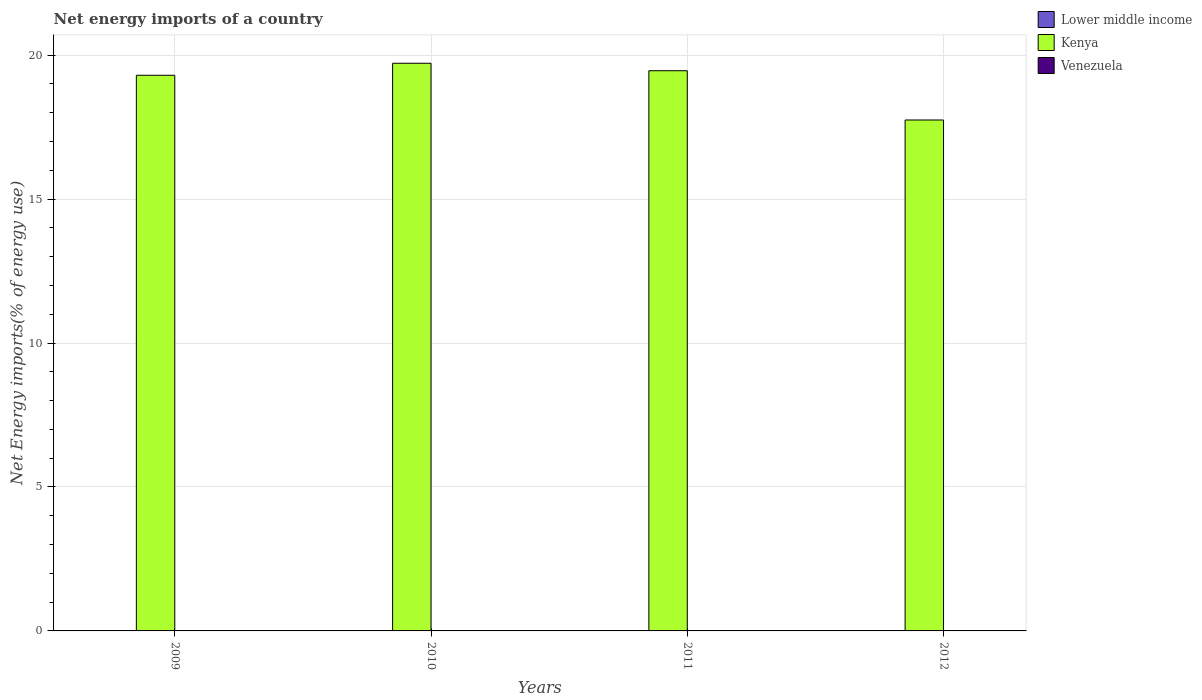How many different coloured bars are there?
Make the answer very short. 1. Are the number of bars on each tick of the X-axis equal?
Provide a short and direct response. Yes. How many bars are there on the 4th tick from the right?
Keep it short and to the point. 1. What is the label of the 3rd group of bars from the left?
Your answer should be very brief. 2011. In how many cases, is the number of bars for a given year not equal to the number of legend labels?
Keep it short and to the point. 4. What is the net energy imports in Kenya in 2010?
Your response must be concise. 19.72. Across all years, what is the maximum net energy imports in Kenya?
Make the answer very short. 19.72. What is the total net energy imports in Kenya in the graph?
Your answer should be very brief. 76.22. What is the difference between the net energy imports in Kenya in 2010 and that in 2011?
Offer a terse response. 0.26. What is the difference between the net energy imports in Kenya in 2011 and the net energy imports in Lower middle income in 2012?
Make the answer very short. 19.46. What is the average net energy imports in Venezuela per year?
Make the answer very short. 0. What is the ratio of the net energy imports in Kenya in 2011 to that in 2012?
Give a very brief answer. 1.1. What is the difference between the highest and the second highest net energy imports in Kenya?
Your answer should be compact. 0.26. What is the difference between the highest and the lowest net energy imports in Kenya?
Make the answer very short. 1.97. Is the sum of the net energy imports in Kenya in 2009 and 2011 greater than the maximum net energy imports in Venezuela across all years?
Offer a very short reply. Yes. How many bars are there?
Your response must be concise. 4. Are all the bars in the graph horizontal?
Give a very brief answer. No. What is the difference between two consecutive major ticks on the Y-axis?
Your answer should be compact. 5. Are the values on the major ticks of Y-axis written in scientific E-notation?
Your response must be concise. No. Does the graph contain any zero values?
Offer a very short reply. Yes. Does the graph contain grids?
Your answer should be very brief. Yes. How many legend labels are there?
Provide a short and direct response. 3. What is the title of the graph?
Provide a short and direct response. Net energy imports of a country. Does "Ghana" appear as one of the legend labels in the graph?
Your response must be concise. No. What is the label or title of the X-axis?
Make the answer very short. Years. What is the label or title of the Y-axis?
Provide a short and direct response. Net Energy imports(% of energy use). What is the Net Energy imports(% of energy use) of Kenya in 2009?
Keep it short and to the point. 19.3. What is the Net Energy imports(% of energy use) of Kenya in 2010?
Provide a short and direct response. 19.72. What is the Net Energy imports(% of energy use) in Venezuela in 2010?
Provide a succinct answer. 0. What is the Net Energy imports(% of energy use) in Kenya in 2011?
Your answer should be compact. 19.46. What is the Net Energy imports(% of energy use) in Kenya in 2012?
Ensure brevity in your answer.  17.75. Across all years, what is the maximum Net Energy imports(% of energy use) in Kenya?
Give a very brief answer. 19.72. Across all years, what is the minimum Net Energy imports(% of energy use) of Kenya?
Your answer should be compact. 17.75. What is the total Net Energy imports(% of energy use) of Lower middle income in the graph?
Offer a terse response. 0. What is the total Net Energy imports(% of energy use) in Kenya in the graph?
Make the answer very short. 76.22. What is the difference between the Net Energy imports(% of energy use) in Kenya in 2009 and that in 2010?
Provide a succinct answer. -0.42. What is the difference between the Net Energy imports(% of energy use) of Kenya in 2009 and that in 2011?
Ensure brevity in your answer.  -0.16. What is the difference between the Net Energy imports(% of energy use) of Kenya in 2009 and that in 2012?
Your answer should be compact. 1.55. What is the difference between the Net Energy imports(% of energy use) in Kenya in 2010 and that in 2011?
Keep it short and to the point. 0.26. What is the difference between the Net Energy imports(% of energy use) of Kenya in 2010 and that in 2012?
Give a very brief answer. 1.97. What is the difference between the Net Energy imports(% of energy use) of Kenya in 2011 and that in 2012?
Offer a very short reply. 1.71. What is the average Net Energy imports(% of energy use) of Lower middle income per year?
Your answer should be very brief. 0. What is the average Net Energy imports(% of energy use) in Kenya per year?
Keep it short and to the point. 19.05. What is the ratio of the Net Energy imports(% of energy use) in Kenya in 2009 to that in 2010?
Make the answer very short. 0.98. What is the ratio of the Net Energy imports(% of energy use) in Kenya in 2009 to that in 2011?
Your answer should be very brief. 0.99. What is the ratio of the Net Energy imports(% of energy use) of Kenya in 2009 to that in 2012?
Offer a very short reply. 1.09. What is the ratio of the Net Energy imports(% of energy use) in Kenya in 2010 to that in 2011?
Provide a short and direct response. 1.01. What is the ratio of the Net Energy imports(% of energy use) of Kenya in 2010 to that in 2012?
Provide a succinct answer. 1.11. What is the ratio of the Net Energy imports(% of energy use) in Kenya in 2011 to that in 2012?
Provide a short and direct response. 1.1. What is the difference between the highest and the second highest Net Energy imports(% of energy use) in Kenya?
Ensure brevity in your answer.  0.26. What is the difference between the highest and the lowest Net Energy imports(% of energy use) in Kenya?
Provide a succinct answer. 1.97. 